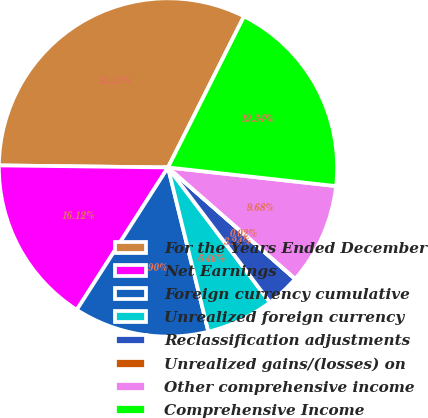Convert chart to OTSL. <chart><loc_0><loc_0><loc_500><loc_500><pie_chart><fcel>For the Years Ended December<fcel>Net Earnings<fcel>Foreign currency cumulative<fcel>Unrealized foreign currency<fcel>Reclassification adjustments<fcel>Unrealized gains/(losses) on<fcel>Other comprehensive income<fcel>Comprehensive Income<nl><fcel>32.22%<fcel>16.12%<fcel>12.9%<fcel>6.46%<fcel>3.24%<fcel>0.02%<fcel>9.68%<fcel>19.34%<nl></chart> 